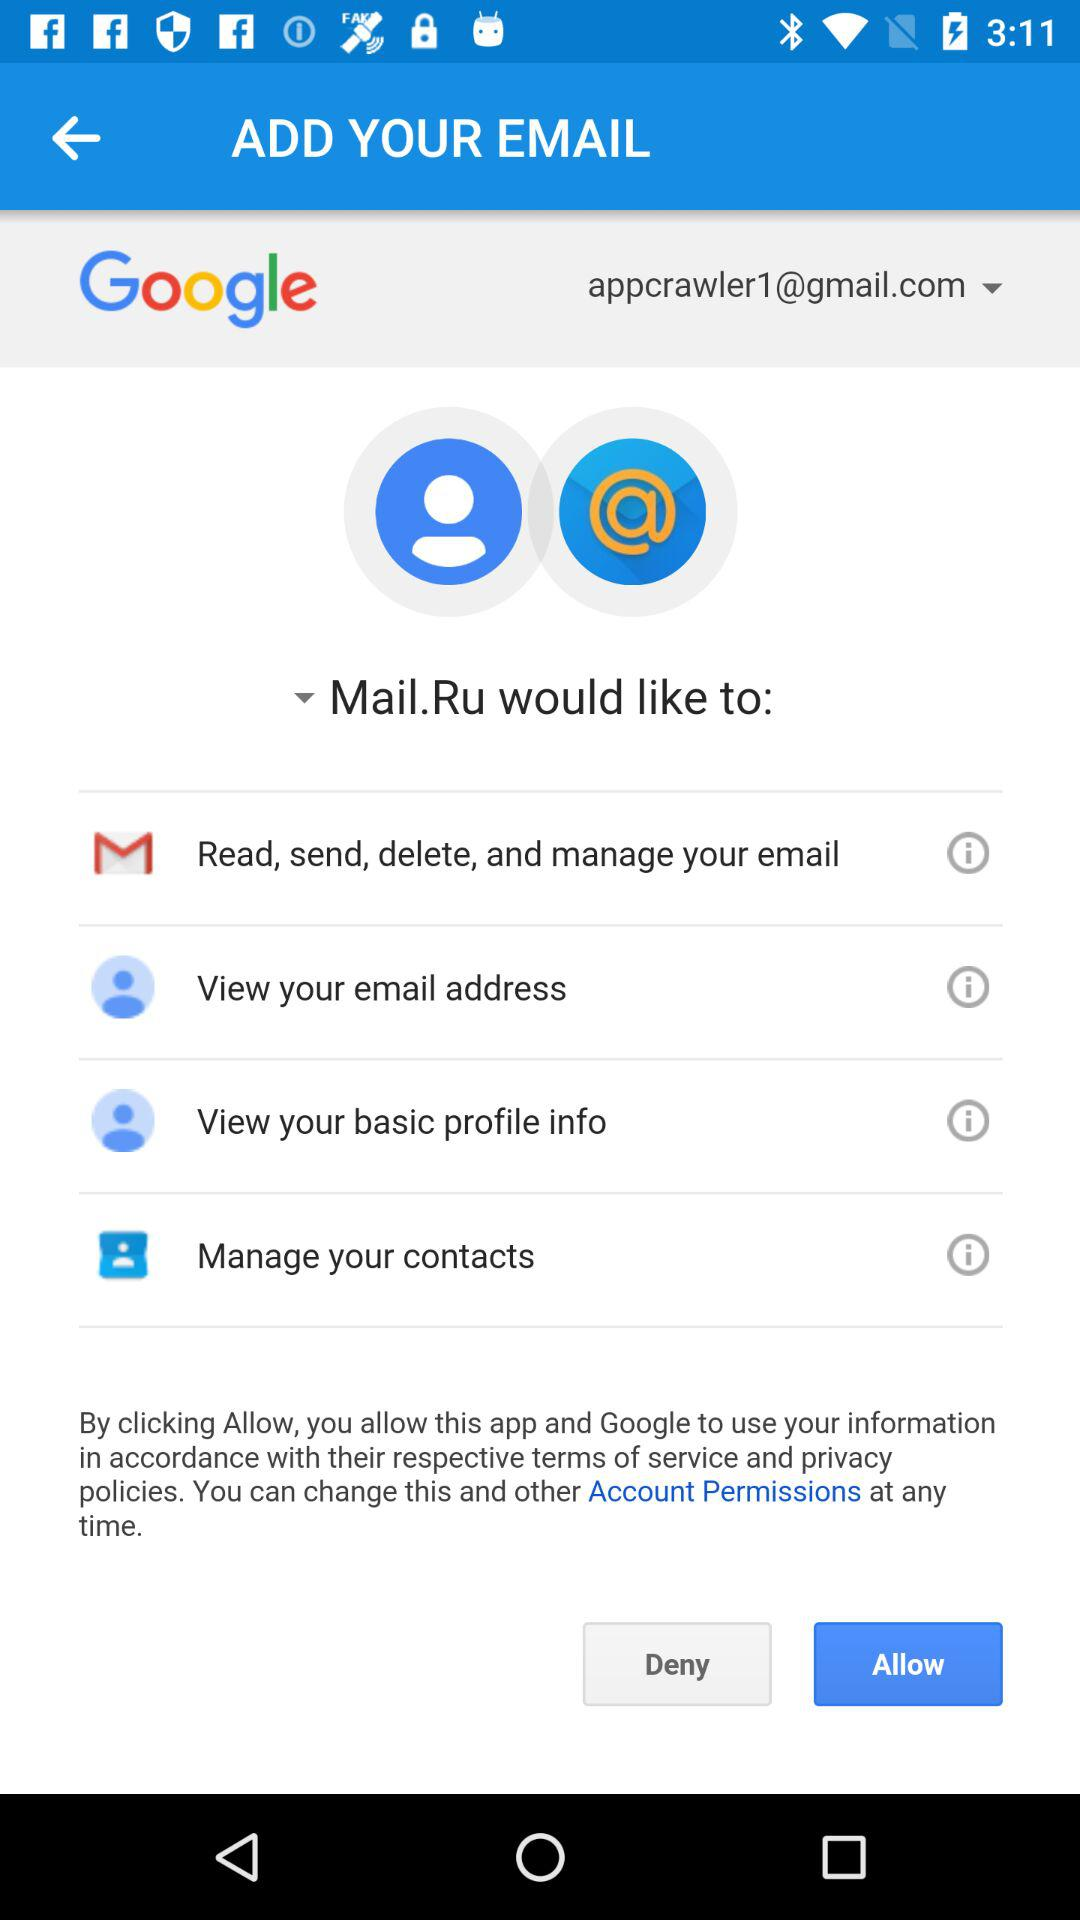What is the email address of the user? The email address of the user is appcrawler1@gmail.com. 